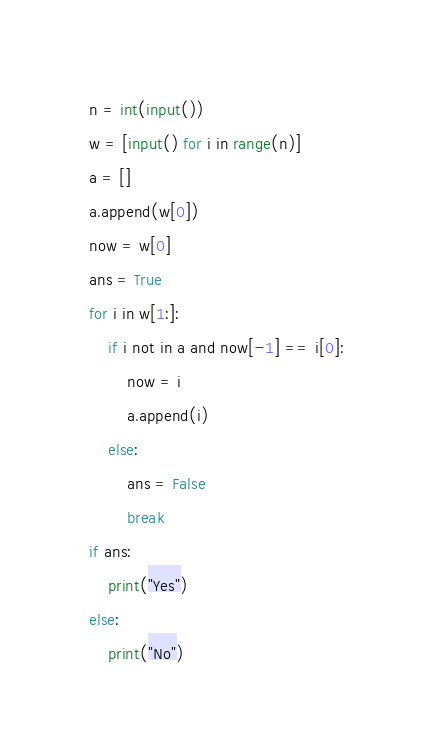<code> <loc_0><loc_0><loc_500><loc_500><_Python_>n = int(input())
w = [input() for i in range(n)]
a = []
a.append(w[0])
now = w[0]
ans = True
for i in w[1:]:
    if i not in a and now[-1] == i[0]:
        now = i
        a.append(i)
    else:
        ans = False
        break
if ans:
    print("Yes")
else:
    print("No")</code> 